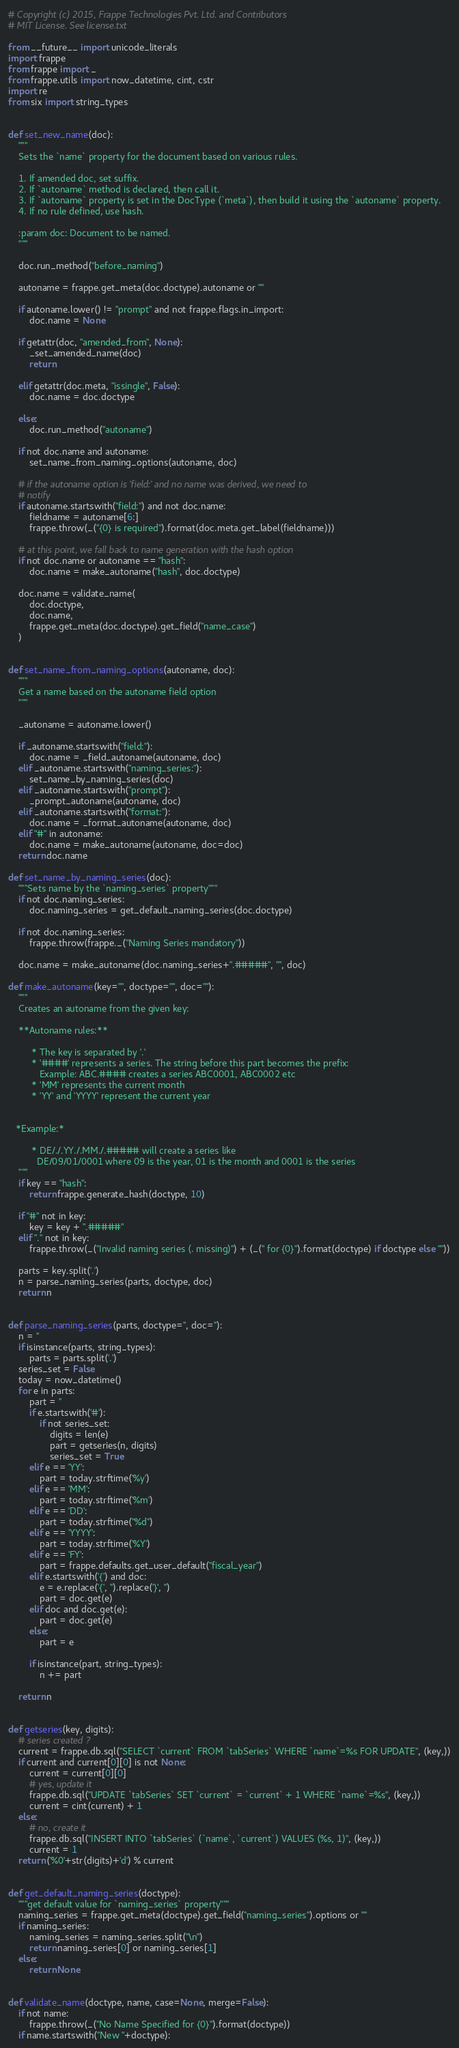<code> <loc_0><loc_0><loc_500><loc_500><_Python_># Copyright (c) 2015, Frappe Technologies Pvt. Ltd. and Contributors
# MIT License. See license.txt

from __future__ import unicode_literals
import frappe
from frappe import _
from frappe.utils import now_datetime, cint, cstr
import re
from six import string_types


def set_new_name(doc):
	"""
	Sets the `name` property for the document based on various rules.

	1. If amended doc, set suffix.
	2. If `autoname` method is declared, then call it.
	3. If `autoname` property is set in the DocType (`meta`), then build it using the `autoname` property.
	4. If no rule defined, use hash.

	:param doc: Document to be named.
	"""

	doc.run_method("before_naming")

	autoname = frappe.get_meta(doc.doctype).autoname or ""

	if autoname.lower() != "prompt" and not frappe.flags.in_import:
		doc.name = None

	if getattr(doc, "amended_from", None):
		_set_amended_name(doc)
		return

	elif getattr(doc.meta, "issingle", False):
		doc.name = doc.doctype

	else:
		doc.run_method("autoname")

	if not doc.name and autoname:
		set_name_from_naming_options(autoname, doc)

	# if the autoname option is 'field:' and no name was derived, we need to
	# notify
	if autoname.startswith("field:") and not doc.name:
		fieldname = autoname[6:]
		frappe.throw(_("{0} is required").format(doc.meta.get_label(fieldname)))

	# at this point, we fall back to name generation with the hash option
	if not doc.name or autoname == "hash":
		doc.name = make_autoname("hash", doc.doctype)

	doc.name = validate_name(
		doc.doctype,
		doc.name,
		frappe.get_meta(doc.doctype).get_field("name_case")
	)


def set_name_from_naming_options(autoname, doc):
	"""
	Get a name based on the autoname field option
	"""

	_autoname = autoname.lower()

	if _autoname.startswith("field:"):
		doc.name = _field_autoname(autoname, doc)
	elif _autoname.startswith("naming_series:"):
		set_name_by_naming_series(doc)
	elif _autoname.startswith("prompt"):
		_prompt_autoname(autoname, doc)
	elif _autoname.startswith("format:"):
		doc.name = _format_autoname(autoname, doc)
	elif "#" in autoname:
		doc.name = make_autoname(autoname, doc=doc)
	return doc.name

def set_name_by_naming_series(doc):
	"""Sets name by the `naming_series` property"""
	if not doc.naming_series:
		doc.naming_series = get_default_naming_series(doc.doctype)

	if not doc.naming_series:
		frappe.throw(frappe._("Naming Series mandatory"))

	doc.name = make_autoname(doc.naming_series+".#####", "", doc)

def make_autoname(key="", doctype="", doc=""):
	"""
	Creates an autoname from the given key:

	**Autoname rules:**

		 * The key is separated by '.'
		 * '####' represents a series. The string before this part becomes the prefix:
			Example: ABC.#### creates a series ABC0001, ABC0002 etc
		 * 'MM' represents the current month
		 * 'YY' and 'YYYY' represent the current year


   *Example:*

		 * DE/./.YY./.MM./.##### will create a series like
		   DE/09/01/0001 where 09 is the year, 01 is the month and 0001 is the series
	"""
	if key == "hash":
		return frappe.generate_hash(doctype, 10)

	if "#" not in key:
		key = key + ".#####"
	elif "." not in key:
		frappe.throw(_("Invalid naming series (. missing)") + (_(" for {0}").format(doctype) if doctype else ""))

	parts = key.split('.')
	n = parse_naming_series(parts, doctype, doc)
	return n


def parse_naming_series(parts, doctype='', doc=''):
	n = ''
	if isinstance(parts, string_types):
		parts = parts.split('.')
	series_set = False
	today = now_datetime()
	for e in parts:
		part = ''
		if e.startswith('#'):
			if not series_set:
				digits = len(e)
				part = getseries(n, digits)
				series_set = True
		elif e == 'YY':
			part = today.strftime('%y')
		elif e == 'MM':
			part = today.strftime('%m')
		elif e == 'DD':
			part = today.strftime("%d")
		elif e == 'YYYY':
			part = today.strftime('%Y')
		elif e == 'FY':
			part = frappe.defaults.get_user_default("fiscal_year")
		elif e.startswith('{') and doc:
			e = e.replace('{', '').replace('}', '')
			part = doc.get(e)
		elif doc and doc.get(e):
			part = doc.get(e)
		else:
			part = e

		if isinstance(part, string_types):
			n += part

	return n


def getseries(key, digits):
	# series created ?
	current = frappe.db.sql("SELECT `current` FROM `tabSeries` WHERE `name`=%s FOR UPDATE", (key,))
	if current and current[0][0] is not None:
		current = current[0][0]
		# yes, update it
		frappe.db.sql("UPDATE `tabSeries` SET `current` = `current` + 1 WHERE `name`=%s", (key,))
		current = cint(current) + 1
	else:
		# no, create it
		frappe.db.sql("INSERT INTO `tabSeries` (`name`, `current`) VALUES (%s, 1)", (key,))
		current = 1
	return ('%0'+str(digits)+'d') % current


def get_default_naming_series(doctype):
	"""get default value for `naming_series` property"""
	naming_series = frappe.get_meta(doctype).get_field("naming_series").options or ""
	if naming_series:
		naming_series = naming_series.split("\n")
		return naming_series[0] or naming_series[1]
	else:
		return None


def validate_name(doctype, name, case=None, merge=False):
	if not name:
		frappe.throw(_("No Name Specified for {0}").format(doctype))
	if name.startswith("New "+doctype):</code> 